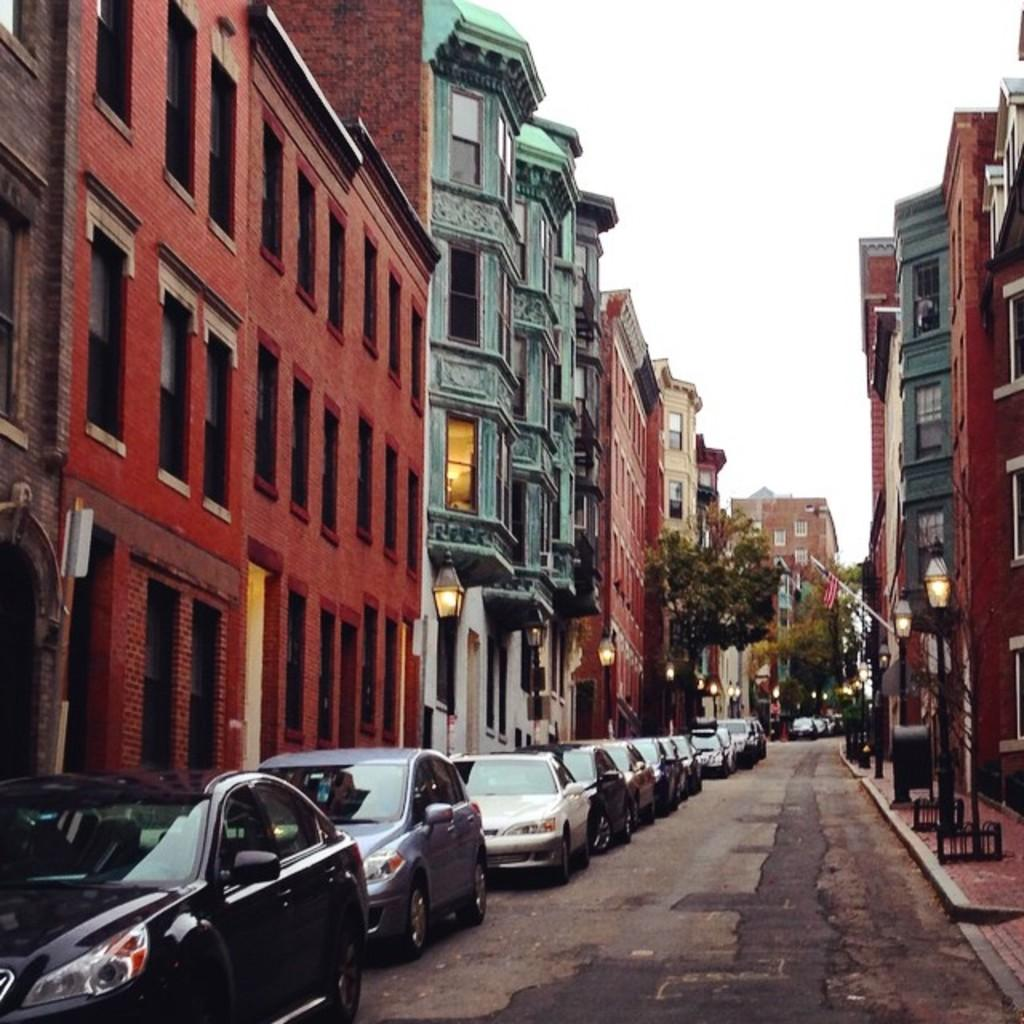What can be seen on the road in the image? There are cars parked on the road in the image. What type of structures are visible in the image? There are buildings visible in the image. What objects are present in the image that are used for supporting or holding something? There are poles in the image. What type of vegetation can be seen in the image? There are trees in the image. What channel is being broadcasted on the television in the image? There is no television present in the image, so it is not possible to determine which channel is being broadcasted. 